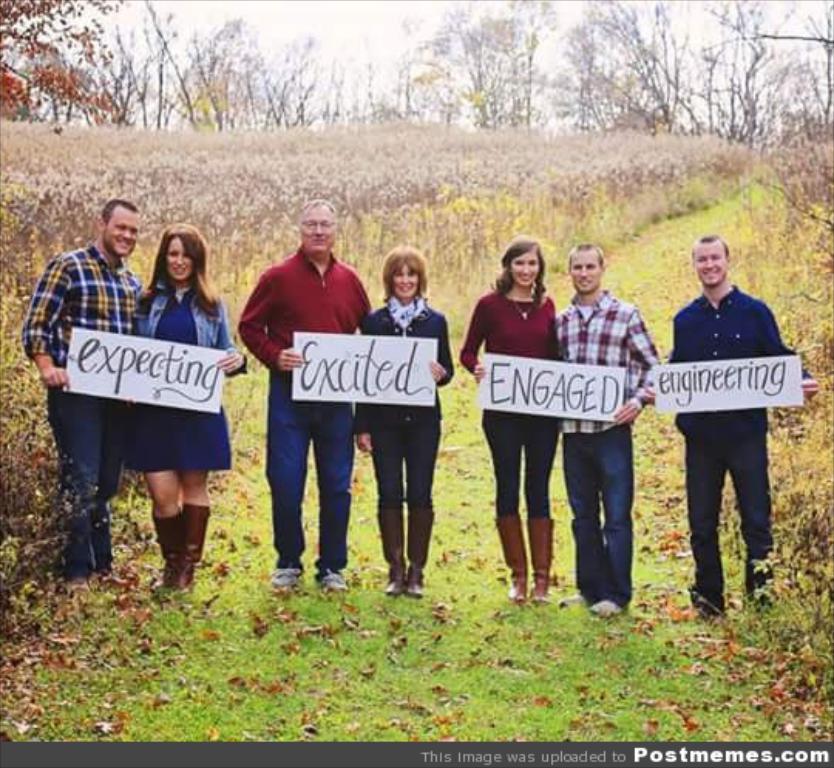Can you describe this image briefly? In the image we can see three women and four men are standing, wearing clothes, shoes and they are smiling, and they are holding posters in their hands. Here we can see grass, dry leaves, plants, trees and the sky. 